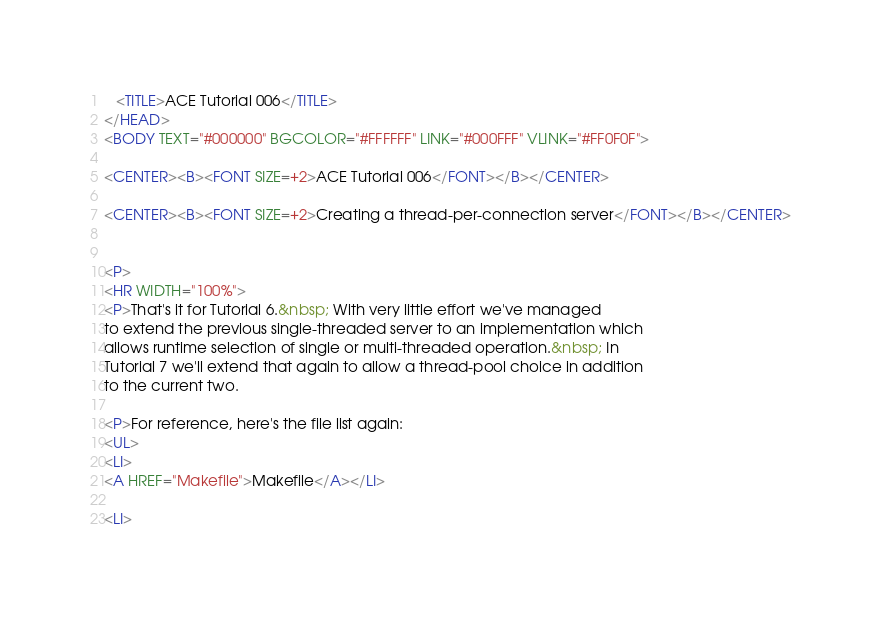Convert code to text. <code><loc_0><loc_0><loc_500><loc_500><_HTML_>   <TITLE>ACE Tutorial 006</TITLE>
</HEAD>
<BODY TEXT="#000000" BGCOLOR="#FFFFFF" LINK="#000FFF" VLINK="#FF0F0F">

<CENTER><B><FONT SIZE=+2>ACE Tutorial 006</FONT></B></CENTER>

<CENTER><B><FONT SIZE=+2>Creating a thread-per-connection server</FONT></B></CENTER>


<P>
<HR WIDTH="100%">
<P>That's it for Tutorial 6.&nbsp; With very little effort we've managed
to extend the previous single-threaded server to an implementation which
allows runtime selection of single or multi-threaded operation.&nbsp; In
Tutorial 7 we'll extend that again to allow a thread-pool choice in addition
to the current two.

<P>For reference, here's the file list again:
<UL>
<LI>
<A HREF="Makefile">Makefile</A></LI>

<LI></code> 